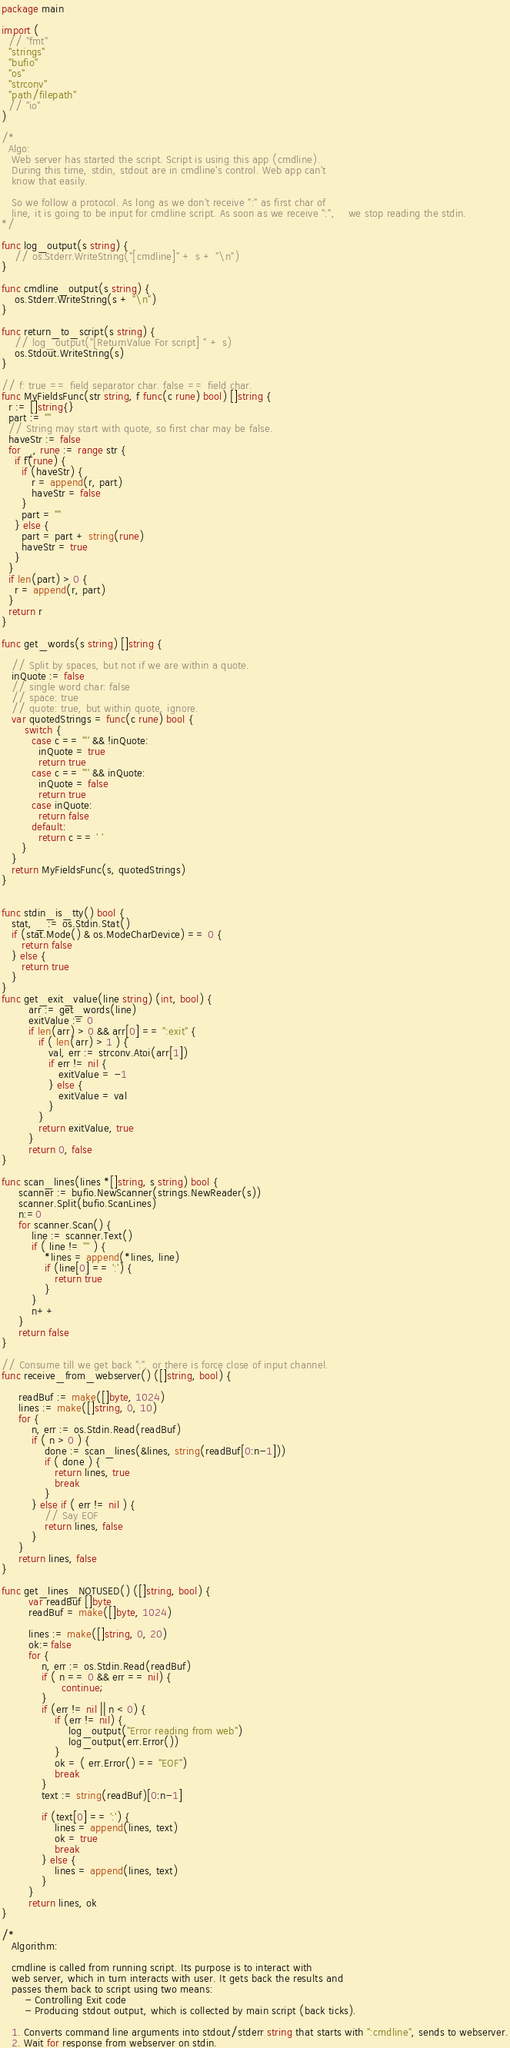<code> <loc_0><loc_0><loc_500><loc_500><_Go_>package main

import (
  // "fmt"
  "strings"
  "bufio"
  "os"
  "strconv"
  "path/filepath"
  // "io"
)

/*
  Algo: 
   Web server has started the script. Script is using this app (cmdline).
   During this time, stdin, stdout are in cmdline's control. Web app can't
   know that easily.

   So we follow a protocol. As long as we don't receive ":" as first char of 
   line, it is going to be input for cmdline script. As soon as we receive ":",    we stop reading the stdin.
*/

func log_output(s string) {
    // os.Stderr.WriteString("[cmdline]" + s + "\n")
}

func cmdline_output(s string) {
    os.Stderr.WriteString(s + "\n")
}

func return_to_script(s string) {
    // log_output("[ReturnValue For script] " + s)
    os.Stdout.WriteString(s)
}

// f: true == field separator char. false == field char.
func MyFieldsFunc(str string, f func(c rune) bool) []string {
  r := []string{}
  part := ""
  // String may start with quote, so first char may be false.
  haveStr := false
  for _, rune := range str {
    if f(rune) {
      if (haveStr) {
         r = append(r, part)
         haveStr = false
      }
      part = ""
    } else {
      part = part + string(rune)
      haveStr = true
    }
  }
  if len(part) > 0 {
    r = append(r, part)
  }
  return r
}

func get_words(s string) []string {

   // Split by spaces, but not if we are within a quote.
   inQuote := false
   // single word char: false
   // space: true
   // quote: true, but within quote, ignore.
   var quotedStrings = func(c rune) bool {
       switch {
         case c == '"' && !inQuote:
           inQuote = true
           return true
         case c == '"' && inQuote:
           inQuote = false
           return true
         case inQuote:
           return false
         default:
           return c == ' '
      }
   }
   return MyFieldsFunc(s, quotedStrings)
}


func stdin_is_tty() bool {
   stat, _ := os.Stdin.Stat()
   if (stat.Mode() & os.ModeCharDevice) == 0 {
      return false 
   } else {
      return true 
   }
}
func get_exit_value(line string) (int, bool) {
        arr := get_words(line)
        exitValue := 0
        if len(arr) > 0 && arr[0] == ":exit" {
           if ( len(arr) > 1 ) {
              val, err := strconv.Atoi(arr[1])
              if err != nil {
                 exitValue = -1
              } else {
                 exitValue = val
              }
           }
           return exitValue, true
        }
        return 0, false
}

func scan_lines(lines *[]string, s string) bool {
     scanner := bufio.NewScanner(strings.NewReader(s))
     scanner.Split(bufio.ScanLines)
     n:=0
     for scanner.Scan() {
         line := scanner.Text()
         if ( line != "" ) {
             *lines = append(*lines, line)
             if (line[0] == ':') {
                return true
             }
         }
         n++
     }
     return false 
}

// Consume till we get back ":", or there is force close of input channel.  
func receive_from_webserver() ([]string, bool) {

     readBuf := make([]byte, 1024)
     lines := make([]string, 0, 10)
     for {
         n, err := os.Stdin.Read(readBuf)
         if ( n > 0 ) {
             done := scan_lines(&lines, string(readBuf[0:n-1]))
             if ( done ) {
                return lines, true
                break
             }
         } else if ( err != nil ) {
             // Say EOF
             return lines, false
         }
     }
     return lines, false
}

func get_lines_NOTUSED() ([]string, bool) {
        var readBuf []byte
        readBuf = make([]byte, 1024)

        lines := make([]string, 0, 20)
        ok:=false
        for {
            n, err := os.Stdin.Read(readBuf)
            if ( n == 0 && err == nil) {
                  continue;
            }
            if (err != nil || n < 0) {
                if (err != nil) {
                    log_output("Error reading from web")
                    log_output(err.Error())
                }
                ok = ( err.Error() == "EOF")
                break
            }
            text := string(readBuf)[0:n-1]

            if (text[0] == ':') {
                lines = append(lines, text)
                ok = true
                break
            } else {
                lines = append(lines, text)
            }
        }
        return lines, ok
}

/*
   Algorithm:

   cmdline is called from running script. Its purpose is to interact with
   web server, which in turn interacts with user. It gets back the results and
   passes them back to script using two means:
       - Controlling Exit code 
       - Producing stdout output, which is collected by main script (back ticks).

   1. Converts command line arguments into stdout/stderr string that starts with ":cmdline", sends to webserver.
   2. Wait for response from webserver on stdin. </code> 